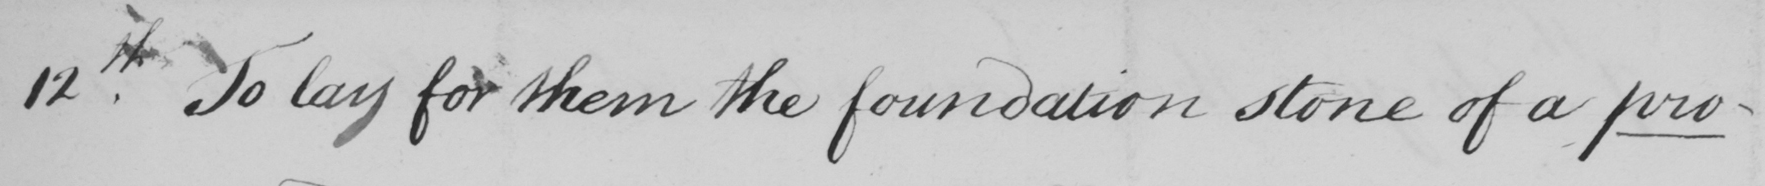What text is written in this handwritten line? 12th . To lay for them the foundation stone of a pro- 